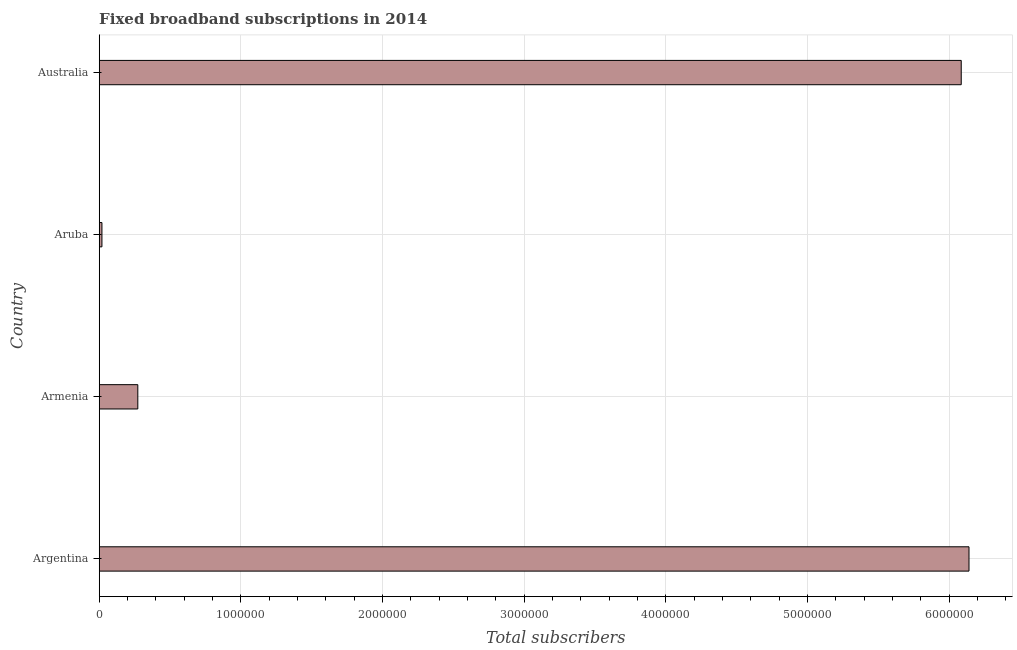What is the title of the graph?
Your answer should be compact. Fixed broadband subscriptions in 2014. What is the label or title of the X-axis?
Your answer should be compact. Total subscribers. What is the label or title of the Y-axis?
Keep it short and to the point. Country. What is the total number of fixed broadband subscriptions in Aruba?
Your response must be concise. 1.92e+04. Across all countries, what is the maximum total number of fixed broadband subscriptions?
Your answer should be compact. 6.14e+06. Across all countries, what is the minimum total number of fixed broadband subscriptions?
Provide a succinct answer. 1.92e+04. In which country was the total number of fixed broadband subscriptions maximum?
Ensure brevity in your answer.  Argentina. In which country was the total number of fixed broadband subscriptions minimum?
Your response must be concise. Aruba. What is the sum of the total number of fixed broadband subscriptions?
Provide a short and direct response. 1.25e+07. What is the difference between the total number of fixed broadband subscriptions in Aruba and Australia?
Provide a succinct answer. -6.07e+06. What is the average total number of fixed broadband subscriptions per country?
Provide a short and direct response. 3.13e+06. What is the median total number of fixed broadband subscriptions?
Provide a short and direct response. 3.18e+06. What is the ratio of the total number of fixed broadband subscriptions in Armenia to that in Aruba?
Provide a succinct answer. 14.2. What is the difference between the highest and the second highest total number of fixed broadband subscriptions?
Keep it short and to the point. 5.49e+04. What is the difference between the highest and the lowest total number of fixed broadband subscriptions?
Ensure brevity in your answer.  6.12e+06. In how many countries, is the total number of fixed broadband subscriptions greater than the average total number of fixed broadband subscriptions taken over all countries?
Make the answer very short. 2. Are all the bars in the graph horizontal?
Your answer should be very brief. Yes. What is the difference between two consecutive major ticks on the X-axis?
Provide a short and direct response. 1.00e+06. Are the values on the major ticks of X-axis written in scientific E-notation?
Offer a very short reply. No. What is the Total subscribers of Argentina?
Provide a short and direct response. 6.14e+06. What is the Total subscribers in Armenia?
Your answer should be compact. 2.73e+05. What is the Total subscribers of Aruba?
Offer a terse response. 1.92e+04. What is the Total subscribers of Australia?
Your response must be concise. 6.09e+06. What is the difference between the Total subscribers in Argentina and Armenia?
Your answer should be very brief. 5.87e+06. What is the difference between the Total subscribers in Argentina and Aruba?
Ensure brevity in your answer.  6.12e+06. What is the difference between the Total subscribers in Argentina and Australia?
Offer a terse response. 5.49e+04. What is the difference between the Total subscribers in Armenia and Aruba?
Keep it short and to the point. 2.53e+05. What is the difference between the Total subscribers in Armenia and Australia?
Make the answer very short. -5.81e+06. What is the difference between the Total subscribers in Aruba and Australia?
Provide a succinct answer. -6.07e+06. What is the ratio of the Total subscribers in Argentina to that in Armenia?
Provide a succinct answer. 22.53. What is the ratio of the Total subscribers in Argentina to that in Aruba?
Offer a very short reply. 319.84. What is the ratio of the Total subscribers in Argentina to that in Australia?
Keep it short and to the point. 1.01. What is the ratio of the Total subscribers in Armenia to that in Aruba?
Your answer should be compact. 14.2. What is the ratio of the Total subscribers in Armenia to that in Australia?
Keep it short and to the point. 0.04. What is the ratio of the Total subscribers in Aruba to that in Australia?
Offer a very short reply. 0. 